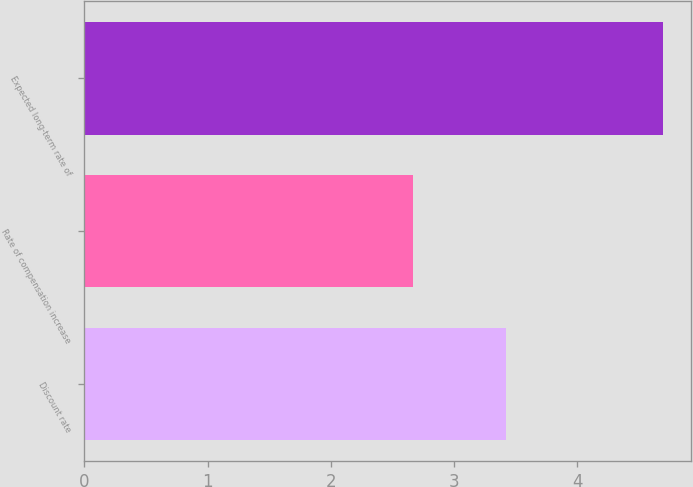Convert chart. <chart><loc_0><loc_0><loc_500><loc_500><bar_chart><fcel>Discount rate<fcel>Rate of compensation increase<fcel>Expected long-term rate of<nl><fcel>3.42<fcel>2.67<fcel>4.69<nl></chart> 